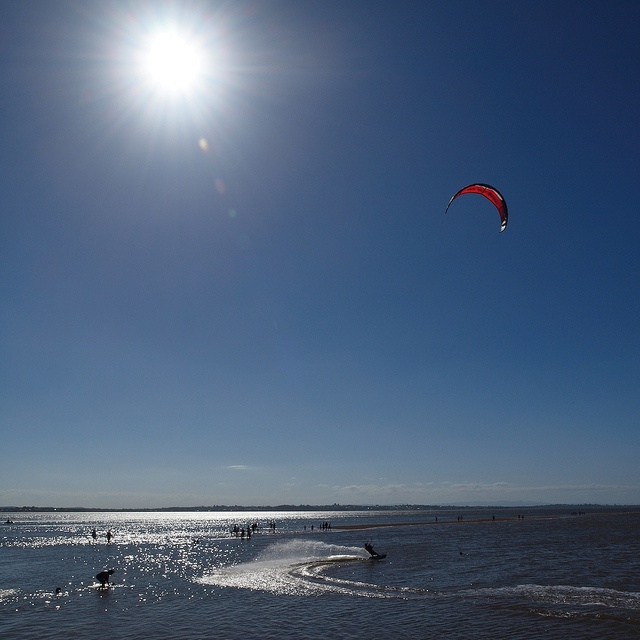Describe the objects in this image and their specific colors. I can see people in blue, black, gray, and darkblue tones, kite in blue, black, maroon, brown, and darkblue tones, people in blue, gray, black, lightgray, and darkgray tones, surfboard in blue, black, gray, lightgray, and darkgray tones, and people in blue, black, gray, and darkgray tones in this image. 